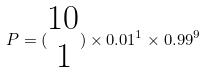Convert formula to latex. <formula><loc_0><loc_0><loc_500><loc_500>P = ( \begin{matrix} 1 0 \\ 1 \end{matrix} ) \times 0 . 0 1 ^ { 1 } \times 0 . 9 9 ^ { 9 }</formula> 